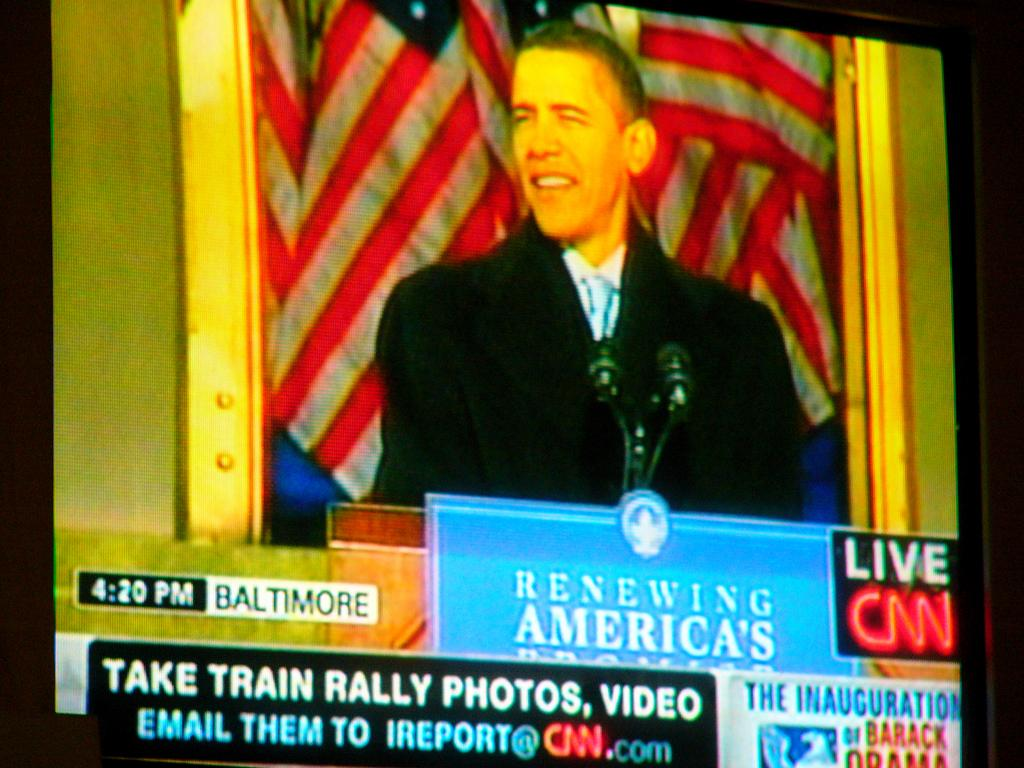Provide a one-sentence caption for the provided image. Screen showing the president and the words "Take Train Rally Photos". 